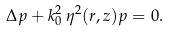<formula> <loc_0><loc_0><loc_500><loc_500>\Delta p + k _ { 0 } ^ { 2 } \, \eta ^ { 2 } ( r , z ) p = 0 .</formula> 